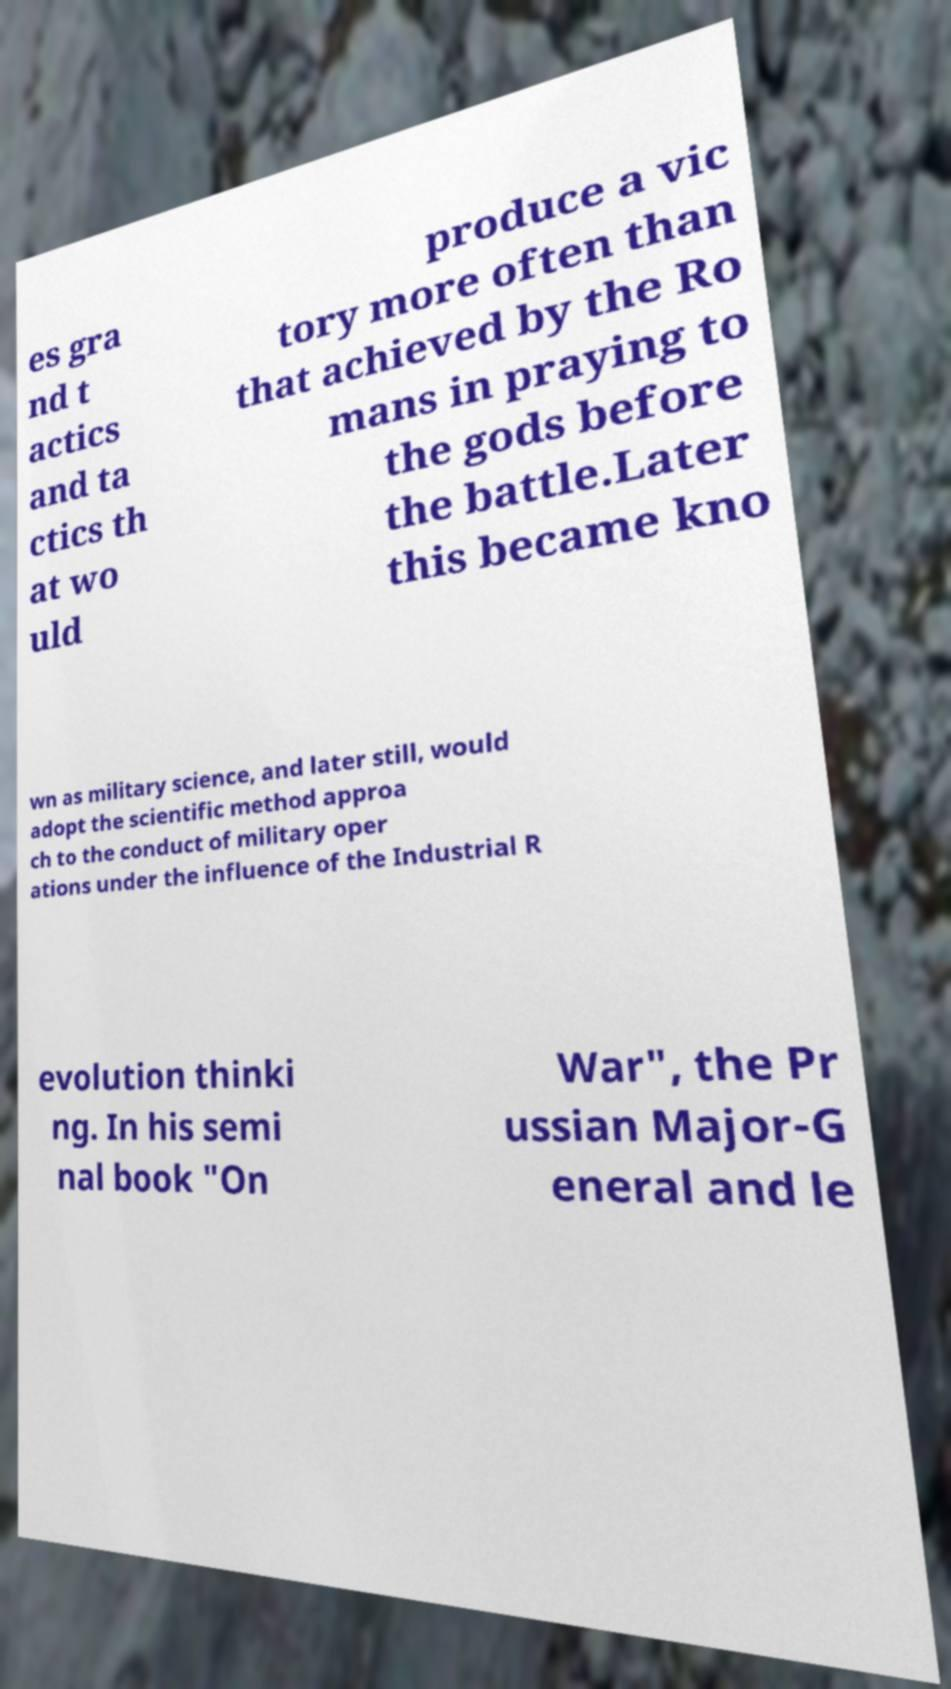For documentation purposes, I need the text within this image transcribed. Could you provide that? es gra nd t actics and ta ctics th at wo uld produce a vic tory more often than that achieved by the Ro mans in praying to the gods before the battle.Later this became kno wn as military science, and later still, would adopt the scientific method approa ch to the conduct of military oper ations under the influence of the Industrial R evolution thinki ng. In his semi nal book "On War", the Pr ussian Major-G eneral and le 